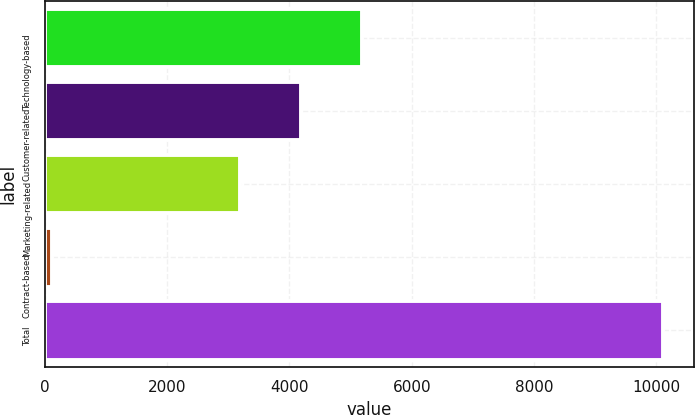Convert chart to OTSL. <chart><loc_0><loc_0><loc_500><loc_500><bar_chart><fcel>Technology-based<fcel>Customer-related<fcel>Marketing-related<fcel>Contract-based<fcel>Total<nl><fcel>5184.4<fcel>4185.7<fcel>3187<fcel>119<fcel>10106<nl></chart> 